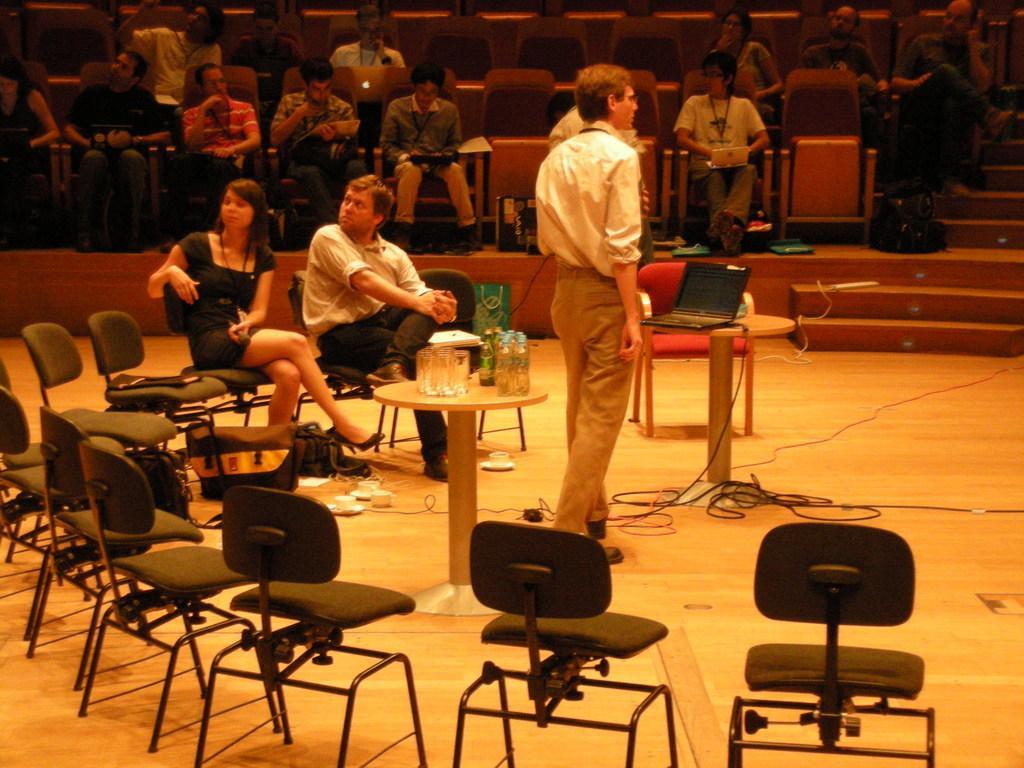Please provide a concise description of this image. This picture is of inside the hall. In the foreground there are many number of chairs. There is a person wearing white color shirt and standing. There are two tables on the top of which glasses, laptop and bottles are placed. There is a woman wearing black color dress and a man wearing white color shirt, sitting on the chairs. In the background there are group of people sitting on the chairs and on the right corner there is a staircase. 